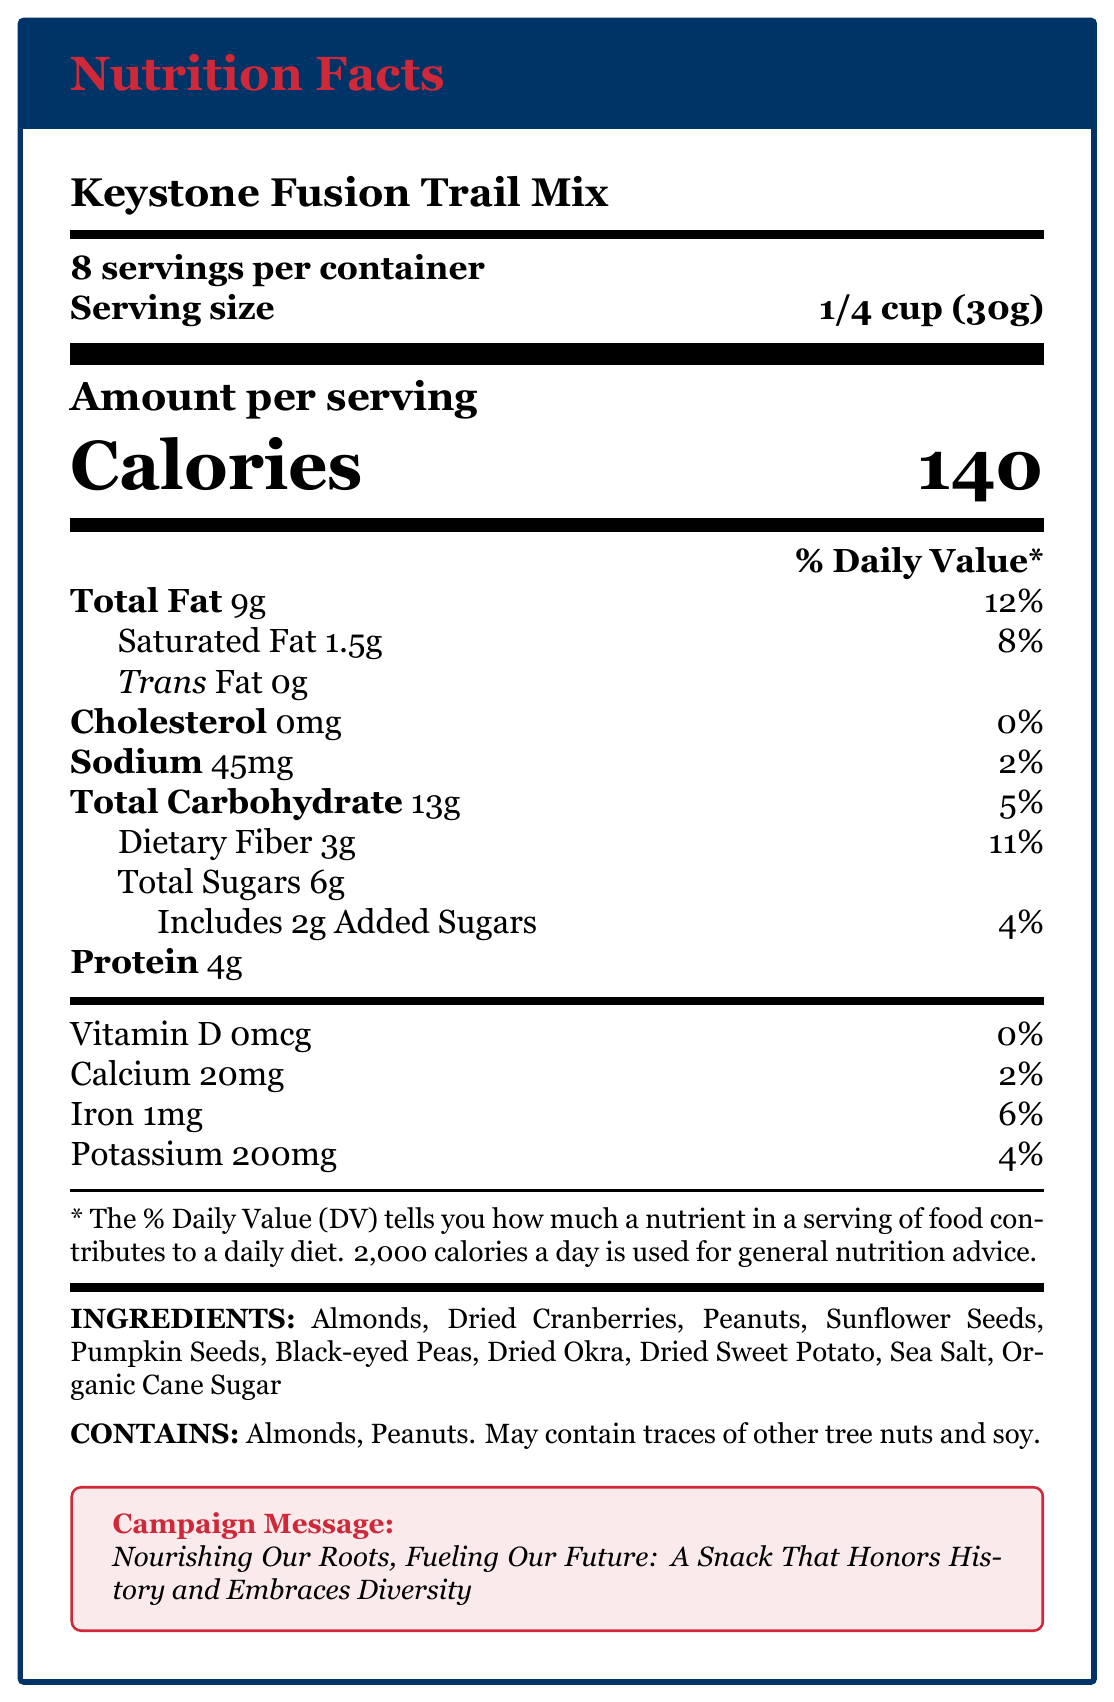How many servings are there per container? The document states there are "8 servings per container."
Answer: 8 How many calories are there per serving? The document specifies "Calories" per serving as 140.
Answer: 140 What is the amount of dietary fiber in one serving? Under the "Total Carbohydrate" section, it lists "Dietary Fiber 3g."
Answer: 3g Which ingredients contribute to the protein content? The "ingredients" list shows "Almonds" and "Peanuts," which are known sources of protein.
Answer: Almonds, Peanuts Does this product contain Vitamin D? The document specifies "Vitamin D 0mcg" with a daily value of "0%."
Answer: No Which of the following ingredients symbolize good luck and prosperity in African American cuisine? A. Sunflower Seeds B. Black-eyed Peas C. Dried Cranberries The document under "cultural_significance" states that black-eyed peas symbolize good luck and prosperity.
Answer: B. Black-eyed Peas What percentage of the daily value of iron does one serving provide? A. 2% B. 4% C. 6% D. 8% The document lists "Iron 1mg" and "6%" under the daily value section.
Answer: C. 6% True or False: The Keystone Fusion Trail Mix includes dried okra. The document lists "Dried Okra" under the "ingredients."
Answer: True Briefly describe the main idea of the Nutrition Facts Label. The document details the nutritional content, cultural significance, and historical connection of the snack, along with a campaign message promoting its diverse and enriching qualities.
Answer: The Keystone Fusion Trail Mix is a culturally significant, historically inspired snack featuring a balanced mix of proteins, healthy fats, and complex carbohydrates, emphasizing diversity and nutrition. Does the product contain any artificial ingredients? The document lists natural ingredients but does not provide specific information about the absence or presence of artificial ingredients.
Answer: Cannot be determined 